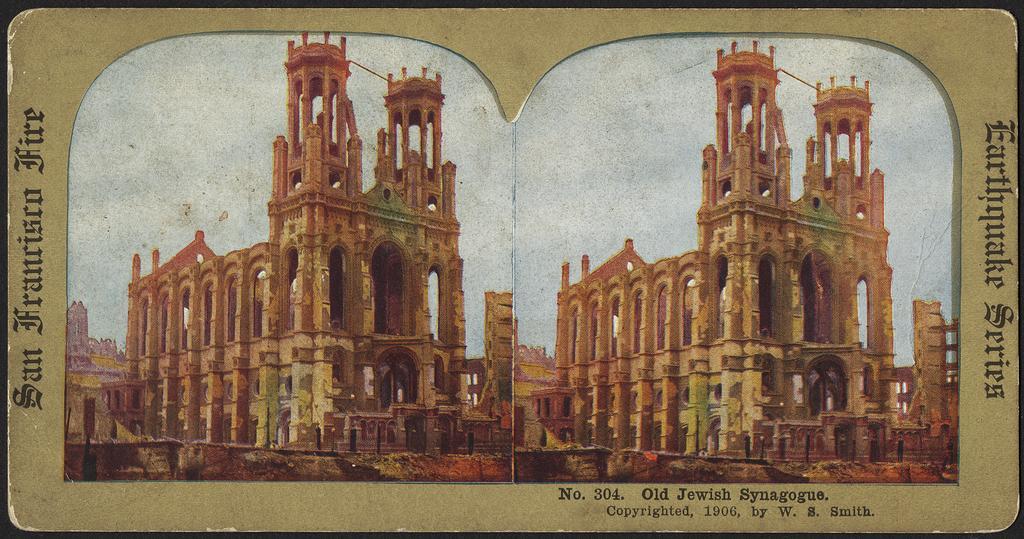Please provide a concise description of this image. In the picture we can see two buildings on left and right side of the picture and we can see some words written on left, right and bottom of the image. 